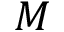Convert formula to latex. <formula><loc_0><loc_0><loc_500><loc_500>M</formula> 